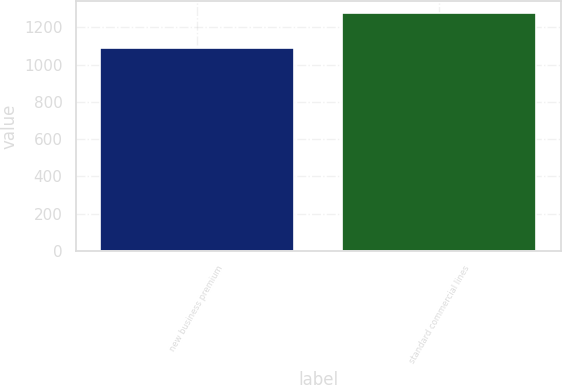Convert chart to OTSL. <chart><loc_0><loc_0><loc_500><loc_500><bar_chart><fcel>new business premium<fcel>standard commercial lines<nl><fcel>1088<fcel>1277<nl></chart> 